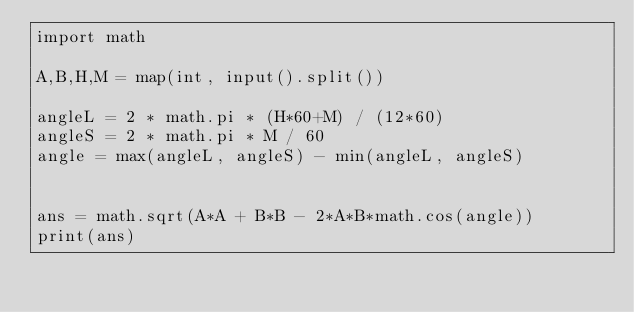<code> <loc_0><loc_0><loc_500><loc_500><_Python_>import math

A,B,H,M = map(int, input().split())

angleL = 2 * math.pi * (H*60+M) / (12*60)
angleS = 2 * math.pi * M / 60
angle = max(angleL, angleS) - min(angleL, angleS)


ans = math.sqrt(A*A + B*B - 2*A*B*math.cos(angle))
print(ans)
</code> 